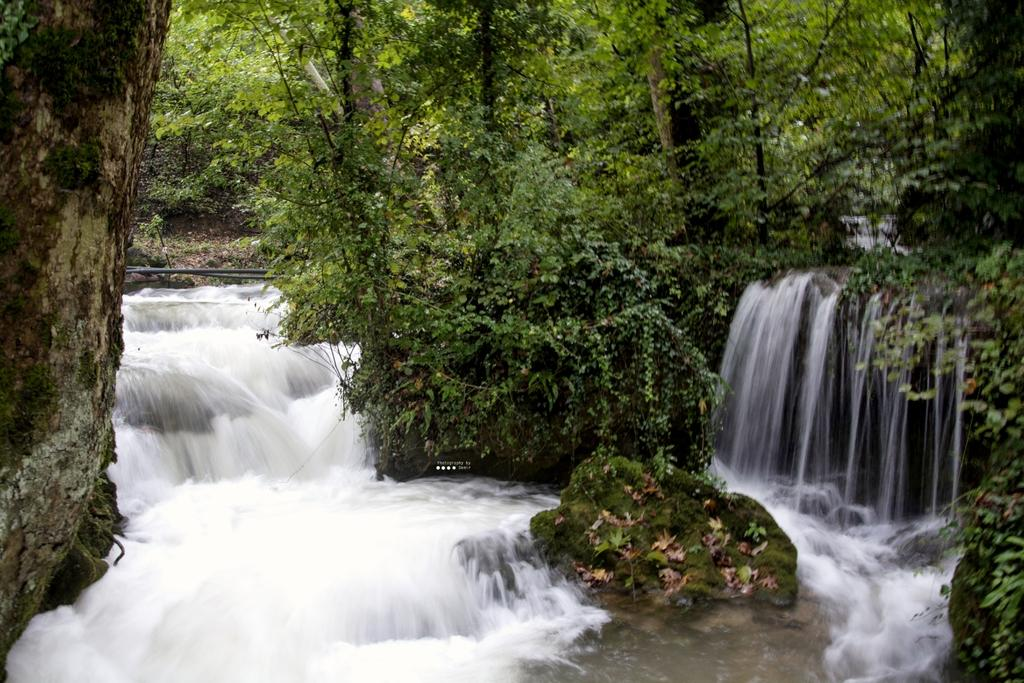What natural feature is the main subject of the image? There is a waterfall in the image. Where is the waterfall located in the image? The waterfall is at the bottom of the image. What can be seen in the background of the image? There are trees in the background of the image. How does the door in the image change its color? There is no door present in the image; it features a waterfall and trees in the background. 